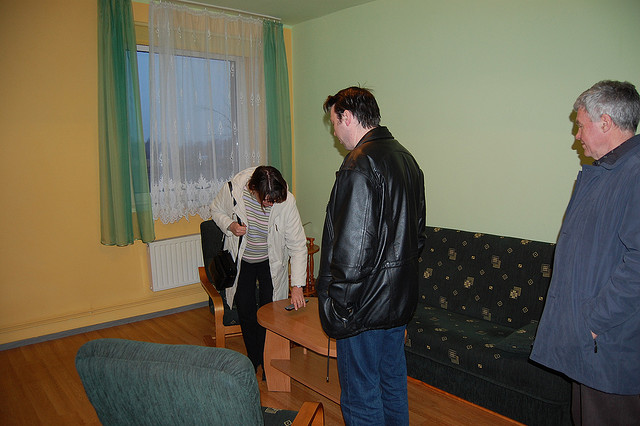<image>Who is the old man in the photo? I don't know who the old man in the photo is. He could be a father, grandpa, person or others. Who is the old man in the photo? I don't know the identity of the old man in the photo. He can be someone's father or grandpa. 